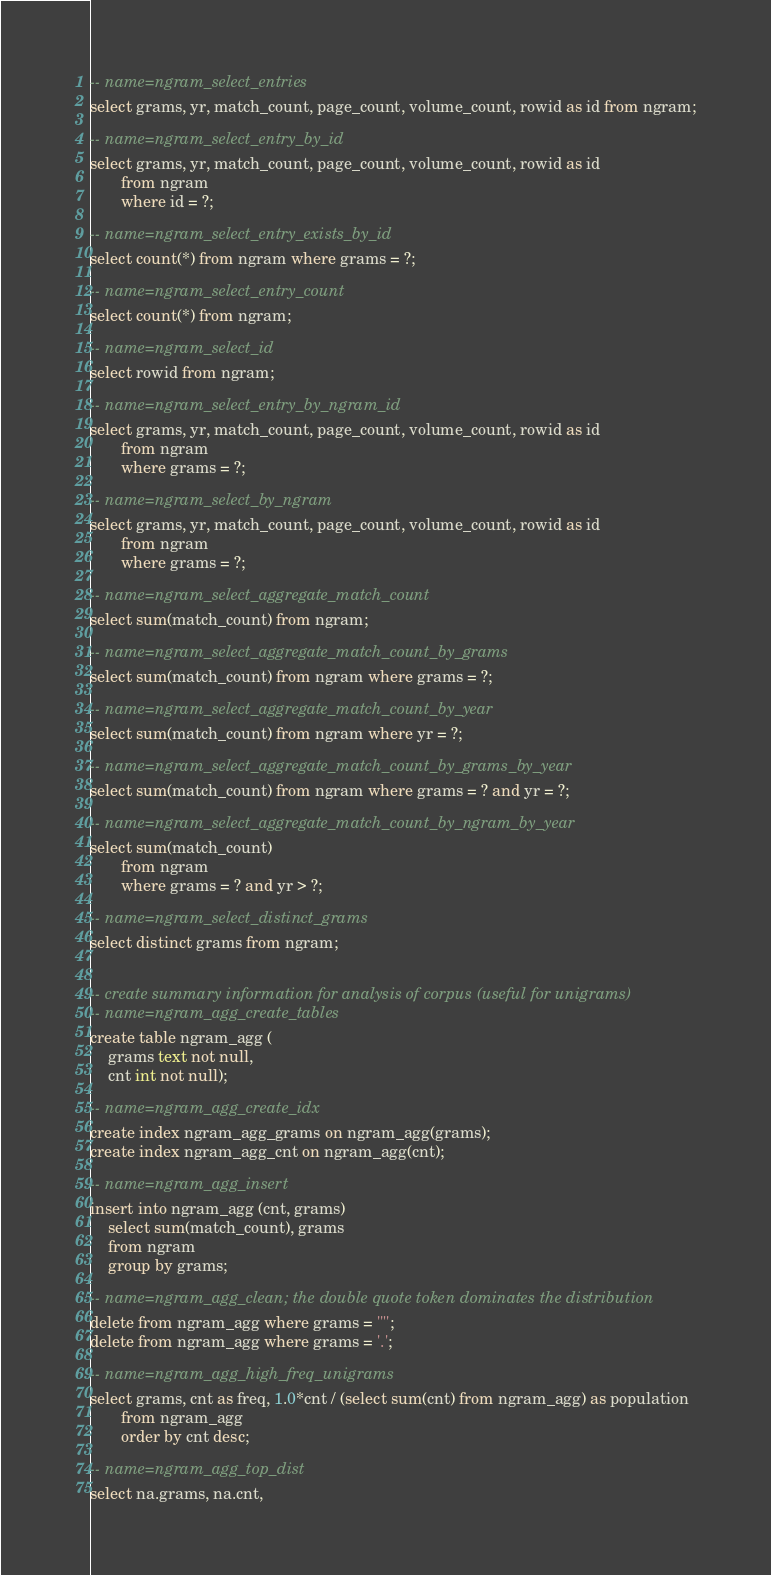<code> <loc_0><loc_0><loc_500><loc_500><_SQL_>
-- name=ngram_select_entries
select grams, yr, match_count, page_count, volume_count, rowid as id from ngram;

-- name=ngram_select_entry_by_id
select grams, yr, match_count, page_count, volume_count, rowid as id
       from ngram
       where id = ?;

-- name=ngram_select_entry_exists_by_id
select count(*) from ngram where grams = ?;

-- name=ngram_select_entry_count
select count(*) from ngram;

-- name=ngram_select_id
select rowid from ngram;

-- name=ngram_select_entry_by_ngram_id
select grams, yr, match_count, page_count, volume_count, rowid as id
       from ngram
       where grams = ?;

-- name=ngram_select_by_ngram
select grams, yr, match_count, page_count, volume_count, rowid as id
       from ngram
       where grams = ?;

-- name=ngram_select_aggregate_match_count
select sum(match_count) from ngram;

-- name=ngram_select_aggregate_match_count_by_grams
select sum(match_count) from ngram where grams = ?;

-- name=ngram_select_aggregate_match_count_by_year
select sum(match_count) from ngram where yr = ?;

-- name=ngram_select_aggregate_match_count_by_grams_by_year
select sum(match_count) from ngram where grams = ? and yr = ?;

-- name=ngram_select_aggregate_match_count_by_ngram_by_year
select sum(match_count)
       from ngram
       where grams = ? and yr > ?;

-- name=ngram_select_distinct_grams
select distinct grams from ngram;


-- create summary information for analysis of corpus (useful for unigrams)
-- name=ngram_agg_create_tables
create table ngram_agg (
    grams text not null,
    cnt int not null);

-- name=ngram_agg_create_idx
create index ngram_agg_grams on ngram_agg(grams);
create index ngram_agg_cnt on ngram_agg(cnt);

-- name=ngram_agg_insert
insert into ngram_agg (cnt, grams)
    select sum(match_count), grams
    from ngram
    group by grams;

-- name=ngram_agg_clean; the double quote token dominates the distribution
delete from ngram_agg where grams = '"';
delete from ngram_agg where grams = '.';

-- name=ngram_agg_high_freq_unigrams
select grams, cnt as freq, 1.0*cnt / (select sum(cnt) from ngram_agg) as population
       from ngram_agg
       order by cnt desc;

-- name=ngram_agg_top_dist
select na.grams, na.cnt,</code> 